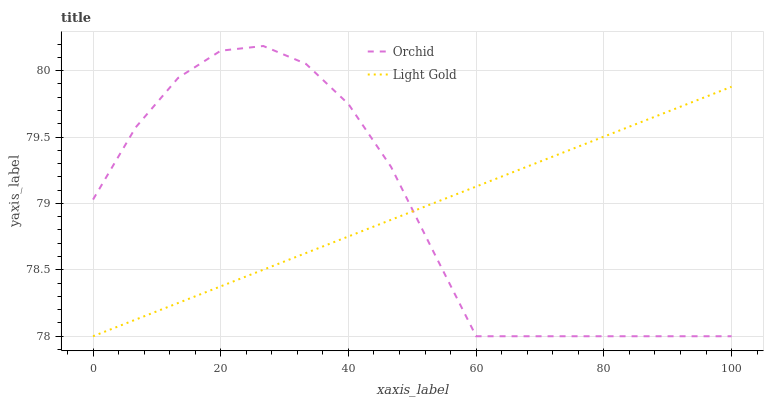Does Orchid have the minimum area under the curve?
Answer yes or no. Yes. Does Light Gold have the maximum area under the curve?
Answer yes or no. Yes. Does Orchid have the maximum area under the curve?
Answer yes or no. No. Is Light Gold the smoothest?
Answer yes or no. Yes. Is Orchid the roughest?
Answer yes or no. Yes. Is Orchid the smoothest?
Answer yes or no. No. Does Light Gold have the lowest value?
Answer yes or no. Yes. Does Orchid have the highest value?
Answer yes or no. Yes. Does Light Gold intersect Orchid?
Answer yes or no. Yes. Is Light Gold less than Orchid?
Answer yes or no. No. Is Light Gold greater than Orchid?
Answer yes or no. No. 